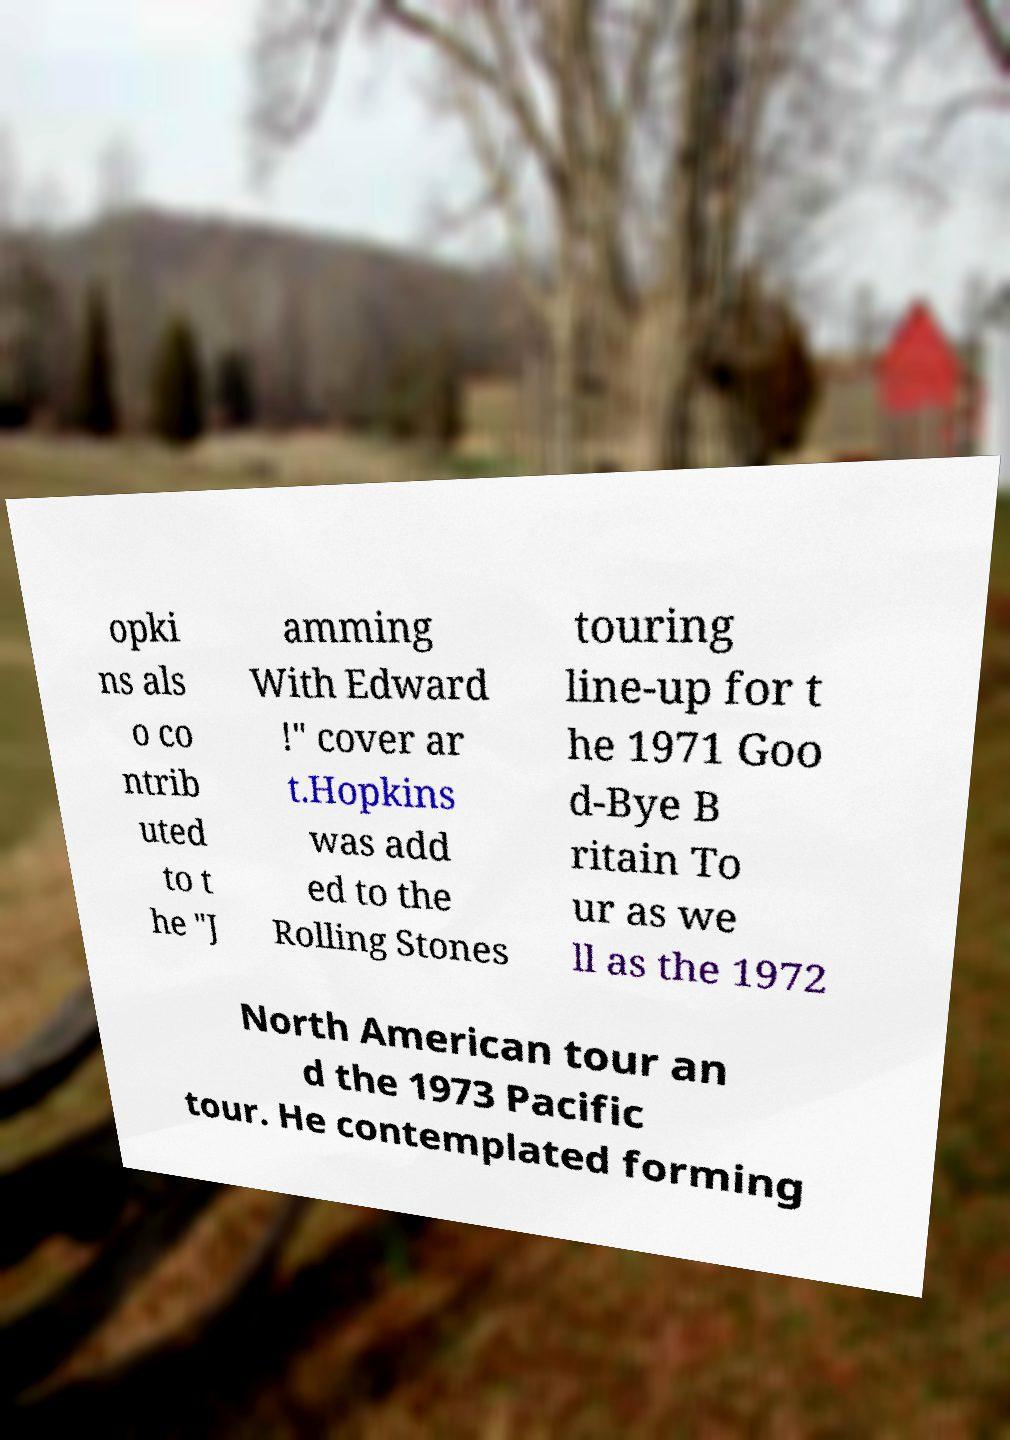There's text embedded in this image that I need extracted. Can you transcribe it verbatim? opki ns als o co ntrib uted to t he "J amming With Edward !" cover ar t.Hopkins was add ed to the Rolling Stones touring line-up for t he 1971 Goo d-Bye B ritain To ur as we ll as the 1972 North American tour an d the 1973 Pacific tour. He contemplated forming 